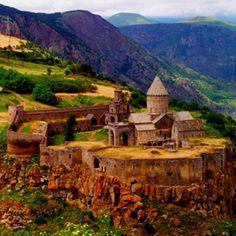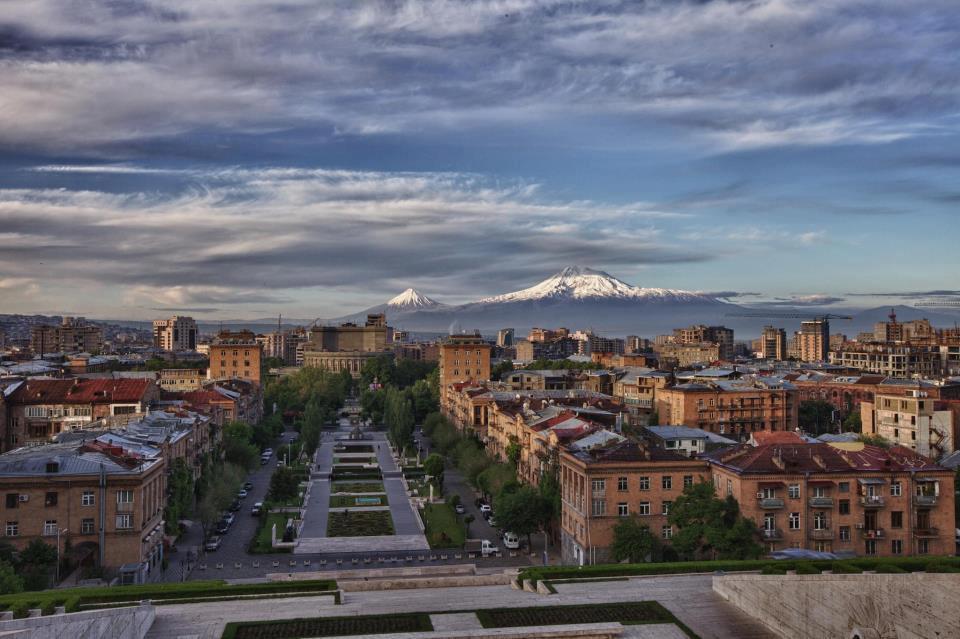The first image is the image on the left, the second image is the image on the right. Examine the images to the left and right. Is the description "Each set of images is actually just two different views of the same building." accurate? Answer yes or no. No. 